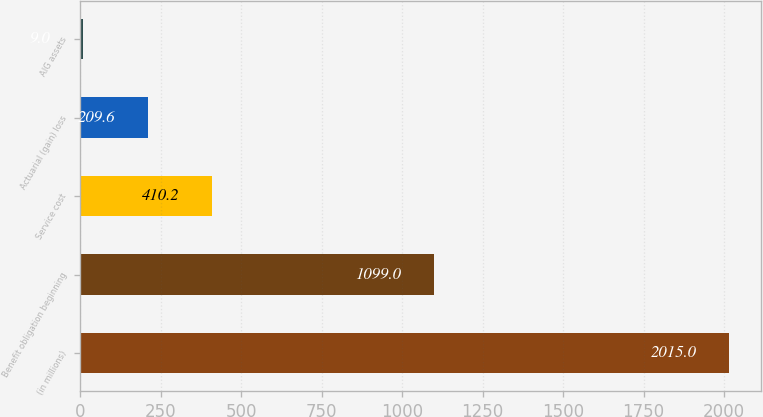<chart> <loc_0><loc_0><loc_500><loc_500><bar_chart><fcel>(in millions)<fcel>Benefit obligation beginning<fcel>Service cost<fcel>Actuarial (gain) loss<fcel>AIG assets<nl><fcel>2015<fcel>1099<fcel>410.2<fcel>209.6<fcel>9<nl></chart> 